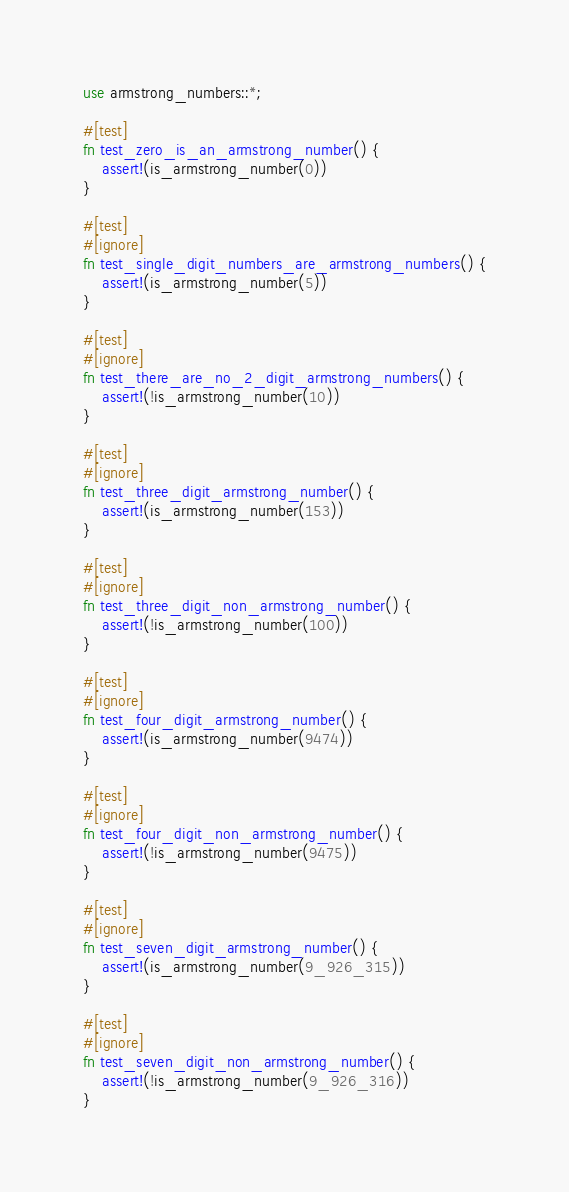Convert code to text. <code><loc_0><loc_0><loc_500><loc_500><_Rust_>use armstrong_numbers::*;

#[test]
fn test_zero_is_an_armstrong_number() {
    assert!(is_armstrong_number(0))
}

#[test]
#[ignore]
fn test_single_digit_numbers_are_armstrong_numbers() {
    assert!(is_armstrong_number(5))
}

#[test]
#[ignore]
fn test_there_are_no_2_digit_armstrong_numbers() {
    assert!(!is_armstrong_number(10))
}

#[test]
#[ignore]
fn test_three_digit_armstrong_number() {
    assert!(is_armstrong_number(153))
}

#[test]
#[ignore]
fn test_three_digit_non_armstrong_number() {
    assert!(!is_armstrong_number(100))
}

#[test]
#[ignore]
fn test_four_digit_armstrong_number() {
    assert!(is_armstrong_number(9474))
}

#[test]
#[ignore]
fn test_four_digit_non_armstrong_number() {
    assert!(!is_armstrong_number(9475))
}

#[test]
#[ignore]
fn test_seven_digit_armstrong_number() {
    assert!(is_armstrong_number(9_926_315))
}

#[test]
#[ignore]
fn test_seven_digit_non_armstrong_number() {
    assert!(!is_armstrong_number(9_926_316))
}
</code> 